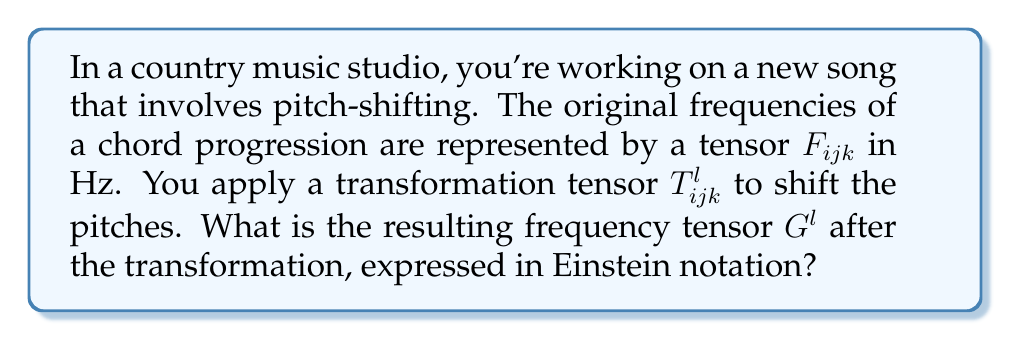What is the answer to this math problem? Let's approach this step-by-step:

1) In tensor notation, the transformation of frequencies can be represented as:

   $$G^l = T^{l}_{ijk} F_{ijk}$$

2) This equation uses Einstein summation convention, which implies summation over repeated indices.

3) Breaking it down:
   - $F_{ijk}$ is the original frequency tensor (3rd order tensor)
   - $T^{l}_{ijk}$ is the transformation tensor (4th order tensor)
   - $G^l$ is the resulting frequency tensor (1st order tensor or vector)

4) The transformation tensor $T^{l}_{ijk}$ maps the 3rd order tensor $F_{ijk}$ to a vector $G^l$.

5) In expanded form, this would be:

   $$G^l = \sum_{i=1}^{3}\sum_{j=1}^{3}\sum_{k=1}^{3} T^{l}_{ijk} F_{ijk}$$

6) This operation essentially "collapses" the 3rd order tensor $F_{ijk}$ into a vector $G^l$, where each component of $G^l$ is a linear combination of all components of $F_{ijk}$, weighted by the corresponding components of $T^{l}_{ijk}$.

7) In the context of music production, this transformation could represent complex frequency shifting operations, where each output frequency is a combination of input frequencies.
Answer: $G^l = T^{l}_{ijk} F_{ijk}$ 